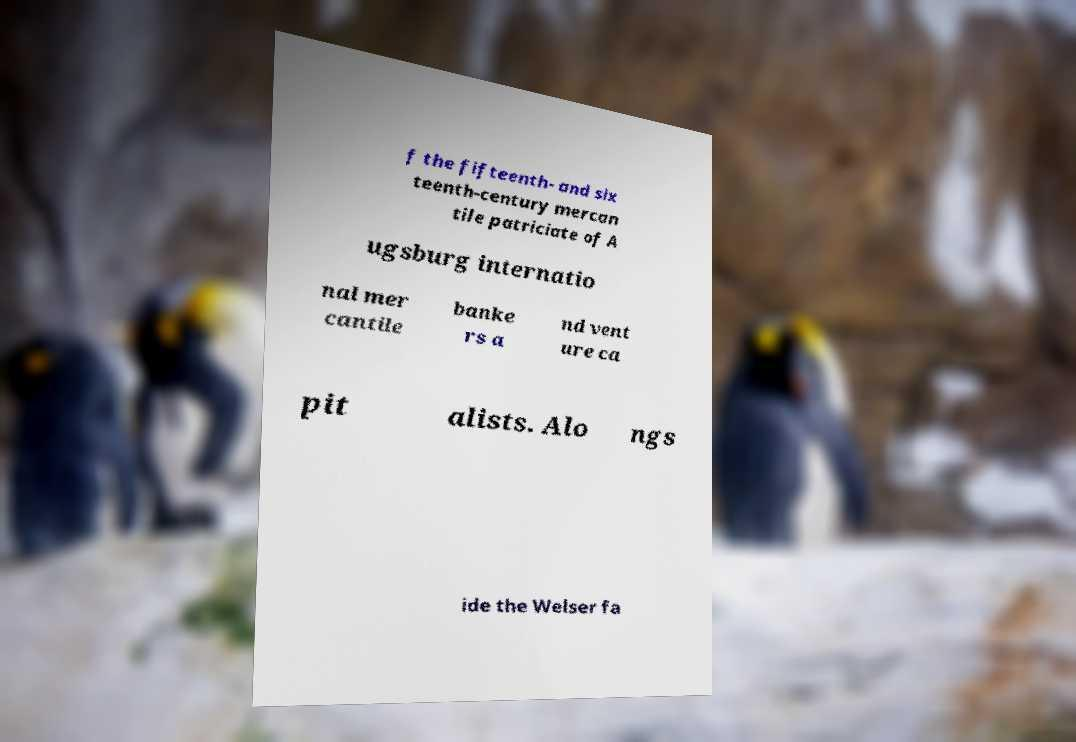Could you extract and type out the text from this image? f the fifteenth- and six teenth-century mercan tile patriciate of A ugsburg internatio nal mer cantile banke rs a nd vent ure ca pit alists. Alo ngs ide the Welser fa 